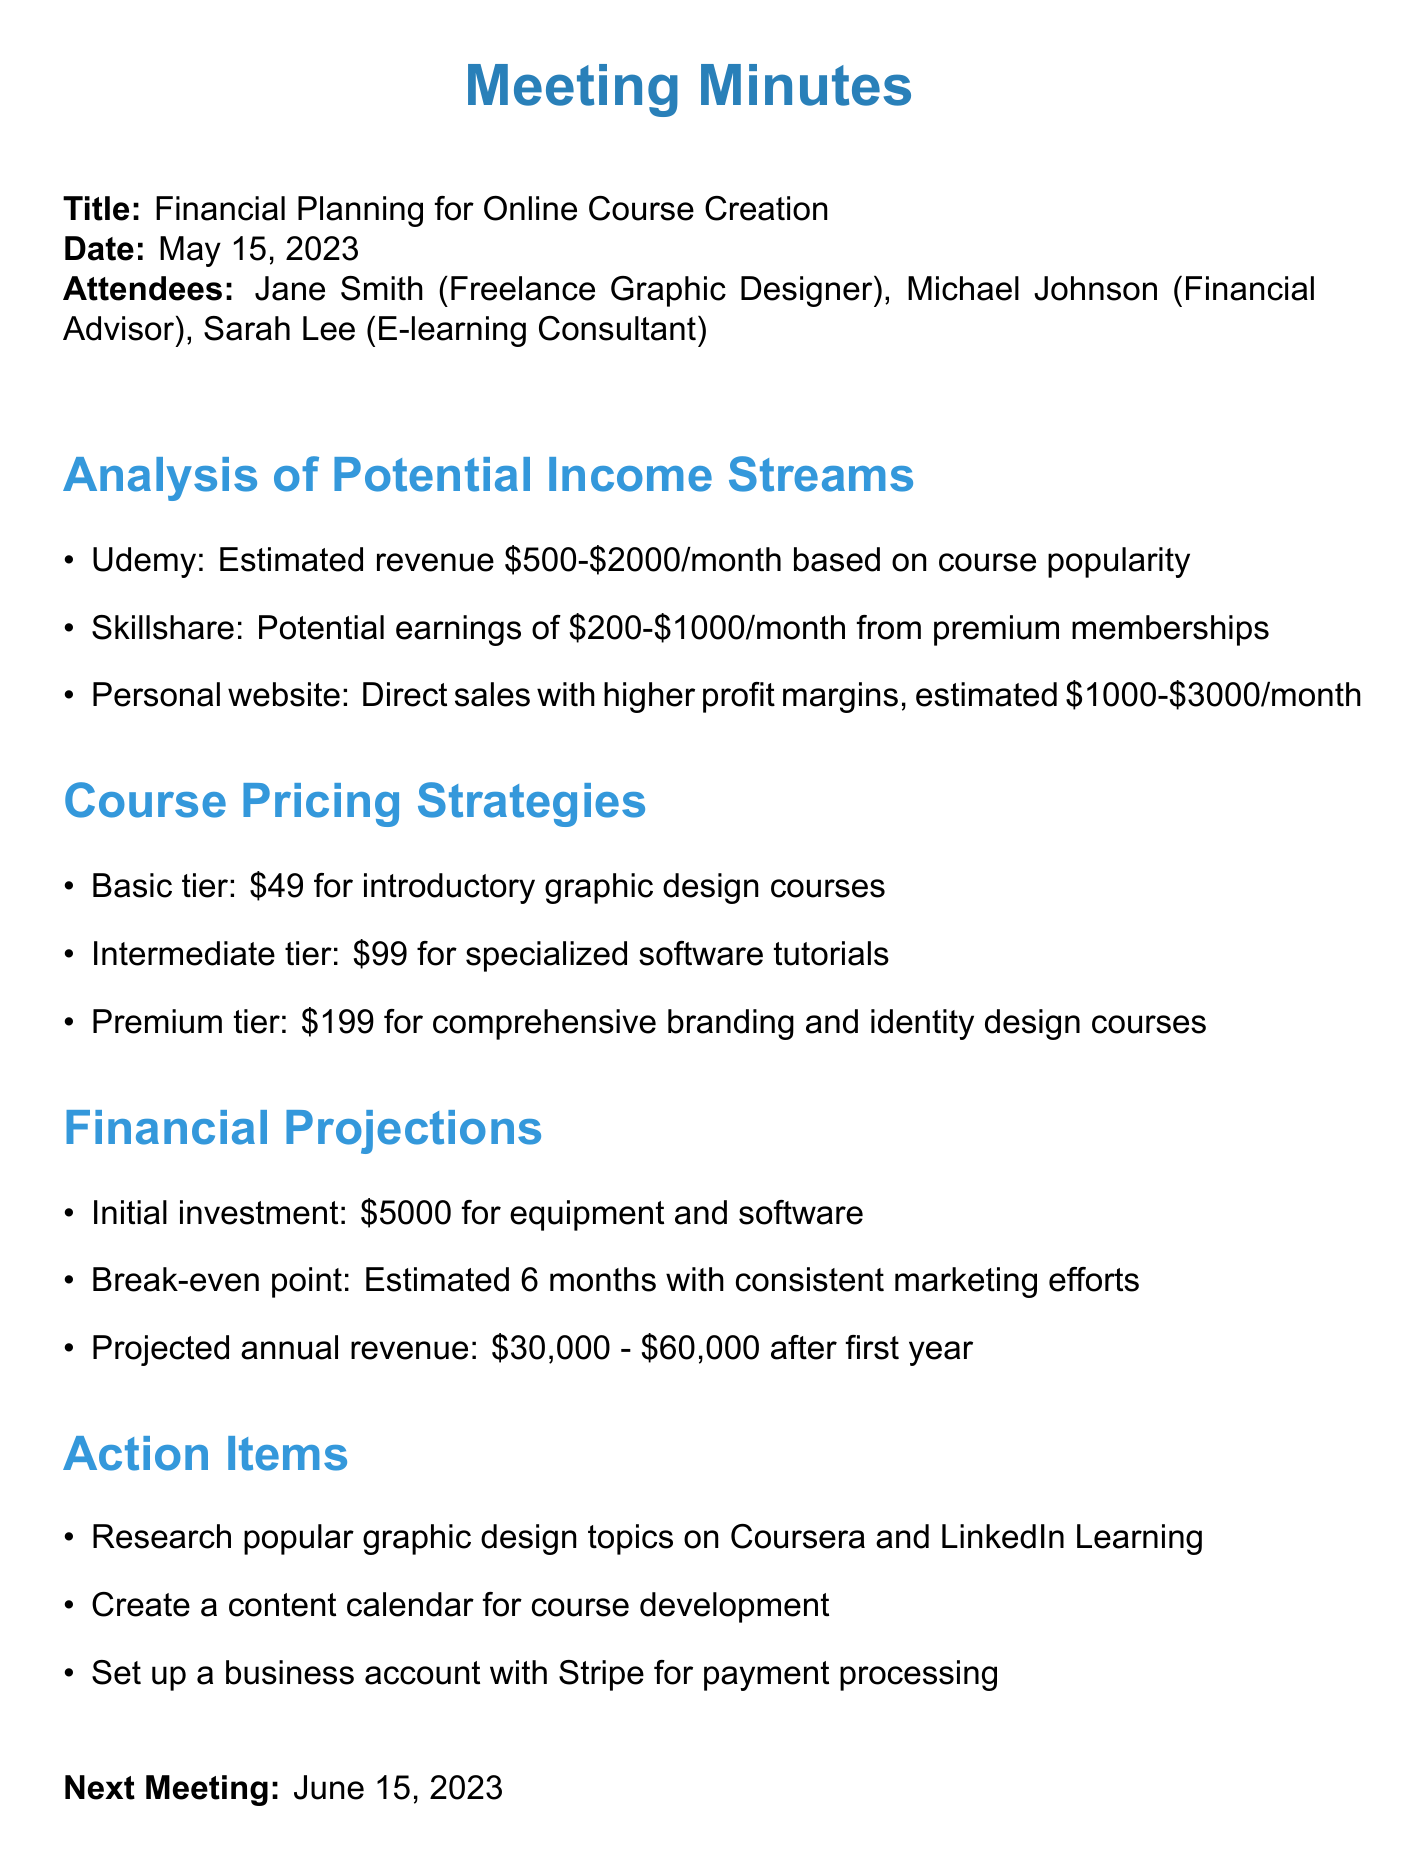what was the date of the meeting? The meeting took place on May 15, 2023.
Answer: May 15, 2023 who attended the meeting? The attendees listed in the document are Jane Smith, Michael Johnson, and Sarah Lee.
Answer: Jane Smith, Michael Johnson, Sarah Lee what is the estimated revenue from Udemy? According to the document, the estimated revenue from Udemy is based on course popularity.
Answer: $500-$2000/month what is the price of the premium tier course? The document specifies the price for the premium tier course.
Answer: $199 what is the projected annual revenue after the first year? The projected annual revenue mentioned in the meeting minutes ranges between two amounts.
Answer: $30,000 - $60,000 what action item involves researching graphic design topics? The action item indicated in the document focuses on researching popular topics on specific platforms.
Answer: Research popular graphic design topics on Coursera and LinkedIn Learning what is the break-even point estimated at? The break-even point is mentioned in the document related to the timeline for investment recovery.
Answer: 6 months how much is the initial investment for creating courses? The document lists the initial investment amount required for equipment and software.
Answer: $5000 